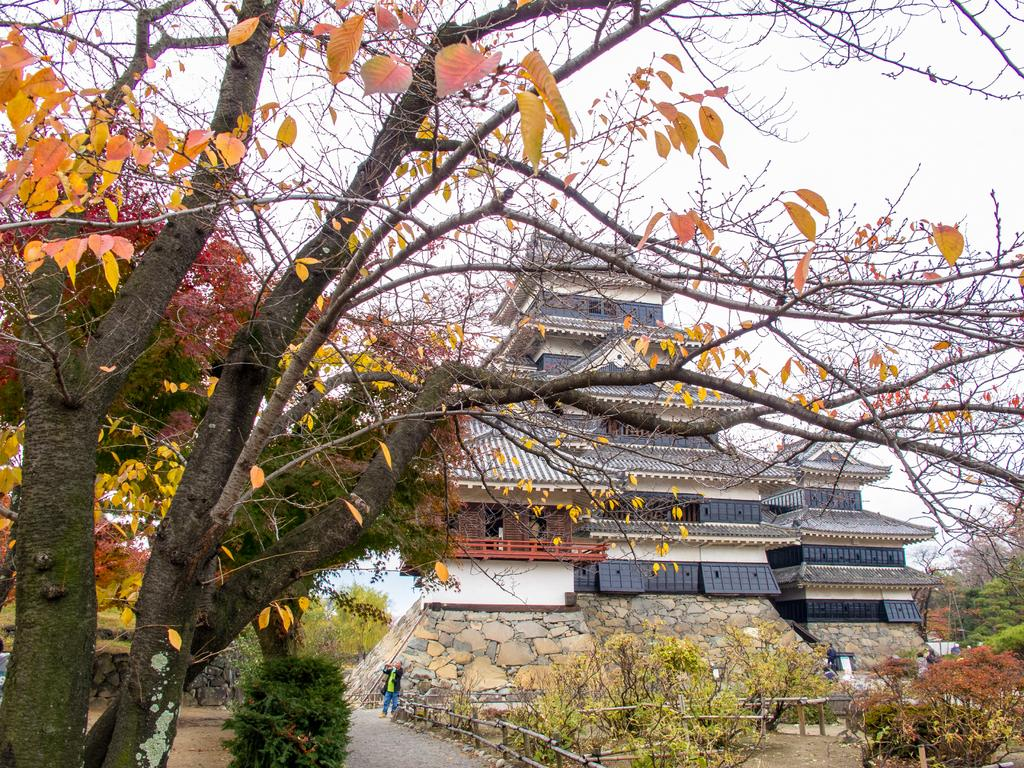What is located on the left side of the image? There is a tree on the left side of the image. What can be seen in the background of the image? Buildings, persons, windows, fences, plants, trees, and the sky are visible in the background of the image. What is the number of veins visible in the image? There are no veins present in the image; it features a tree, buildings, persons, windows, fences, plants, trees, and the sky. 